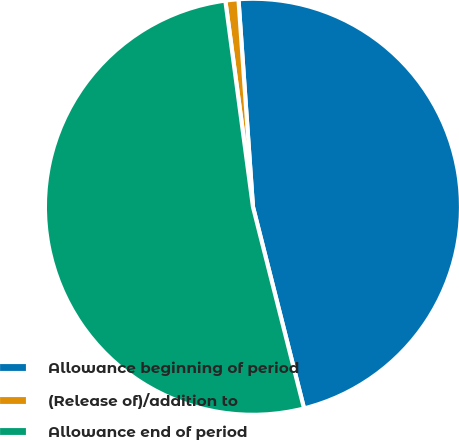Convert chart. <chart><loc_0><loc_0><loc_500><loc_500><pie_chart><fcel>Allowance beginning of period<fcel>(Release of)/addition to<fcel>Allowance end of period<nl><fcel>47.16%<fcel>1.01%<fcel>51.83%<nl></chart> 